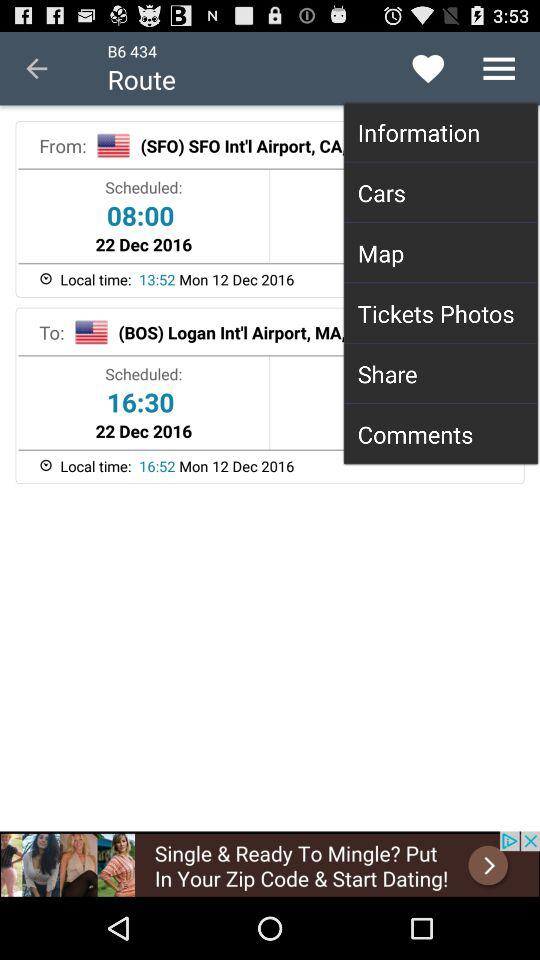What is the scheduled time to reach the destination? The scheduled time to reach the destination is 16:30. 